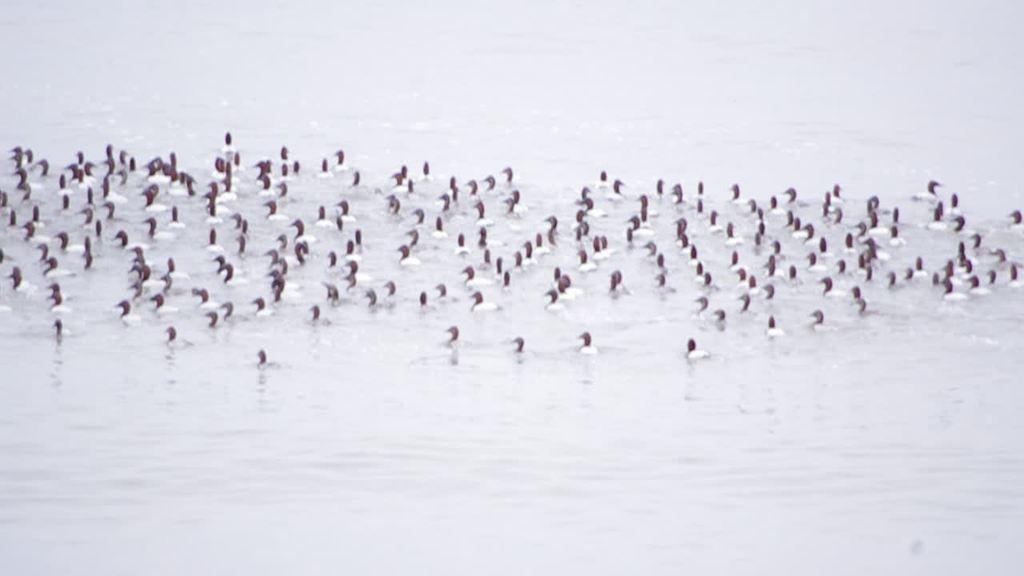What type of animals can be seen in the image? Birds can be seen in the image. Where are the birds located in the image? The birds are in the water. What colors are the birds in the image? The birds are in white and black color. Are there any boats in the image? No, there are no boats present in the image. Can the birds fly in the image? The image does not show the birds flying, but it is possible that they can fly. 